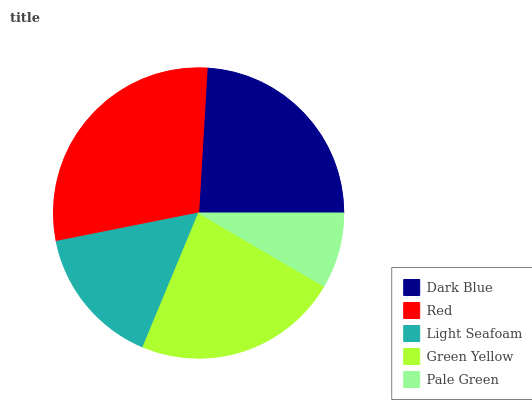Is Pale Green the minimum?
Answer yes or no. Yes. Is Red the maximum?
Answer yes or no. Yes. Is Light Seafoam the minimum?
Answer yes or no. No. Is Light Seafoam the maximum?
Answer yes or no. No. Is Red greater than Light Seafoam?
Answer yes or no. Yes. Is Light Seafoam less than Red?
Answer yes or no. Yes. Is Light Seafoam greater than Red?
Answer yes or no. No. Is Red less than Light Seafoam?
Answer yes or no. No. Is Green Yellow the high median?
Answer yes or no. Yes. Is Green Yellow the low median?
Answer yes or no. Yes. Is Pale Green the high median?
Answer yes or no. No. Is Dark Blue the low median?
Answer yes or no. No. 